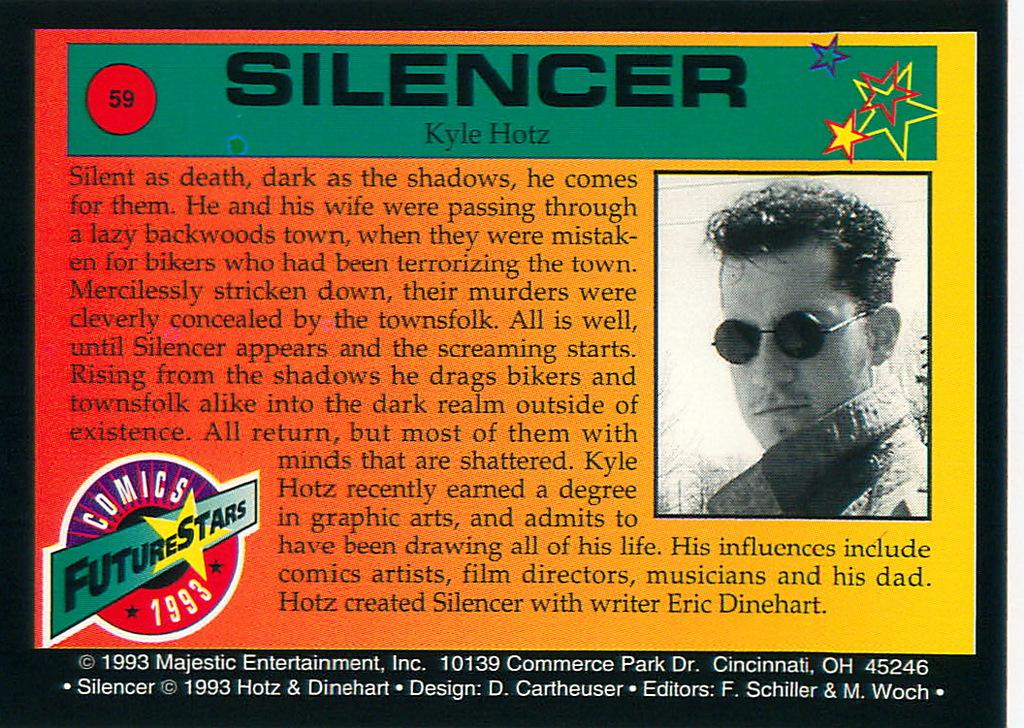What is present in the image that contains information or a message? There is a poster in the image. What can be found on the poster besides the image of a person? There is text written on the poster. What type of image is depicted on the poster? There is an image of a person on the poster. Where is the plantation located in the image? There is no plantation present in the image. What direction is the person on the poster facing? The provided facts do not mention the direction the person is facing, so we cannot answer this question definitively. 